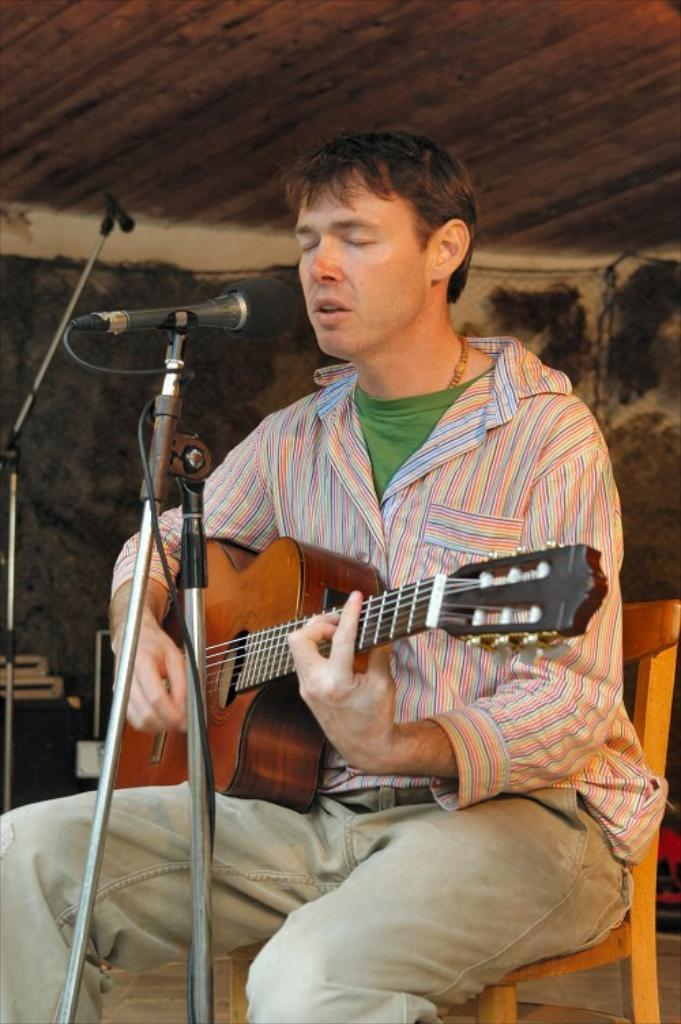What is the person in the image doing? The person is sitting, playing a guitar, and singing. What object is the person using to amplify their voice? There is a microphone in the image. What can be seen in the background of the image? There is a box in the background of the image. What type of treatment is the person receiving in the image? There is no indication in the image that the person is receiving any treatment. How many houses are visible in the image? There are no houses visible in the image. 